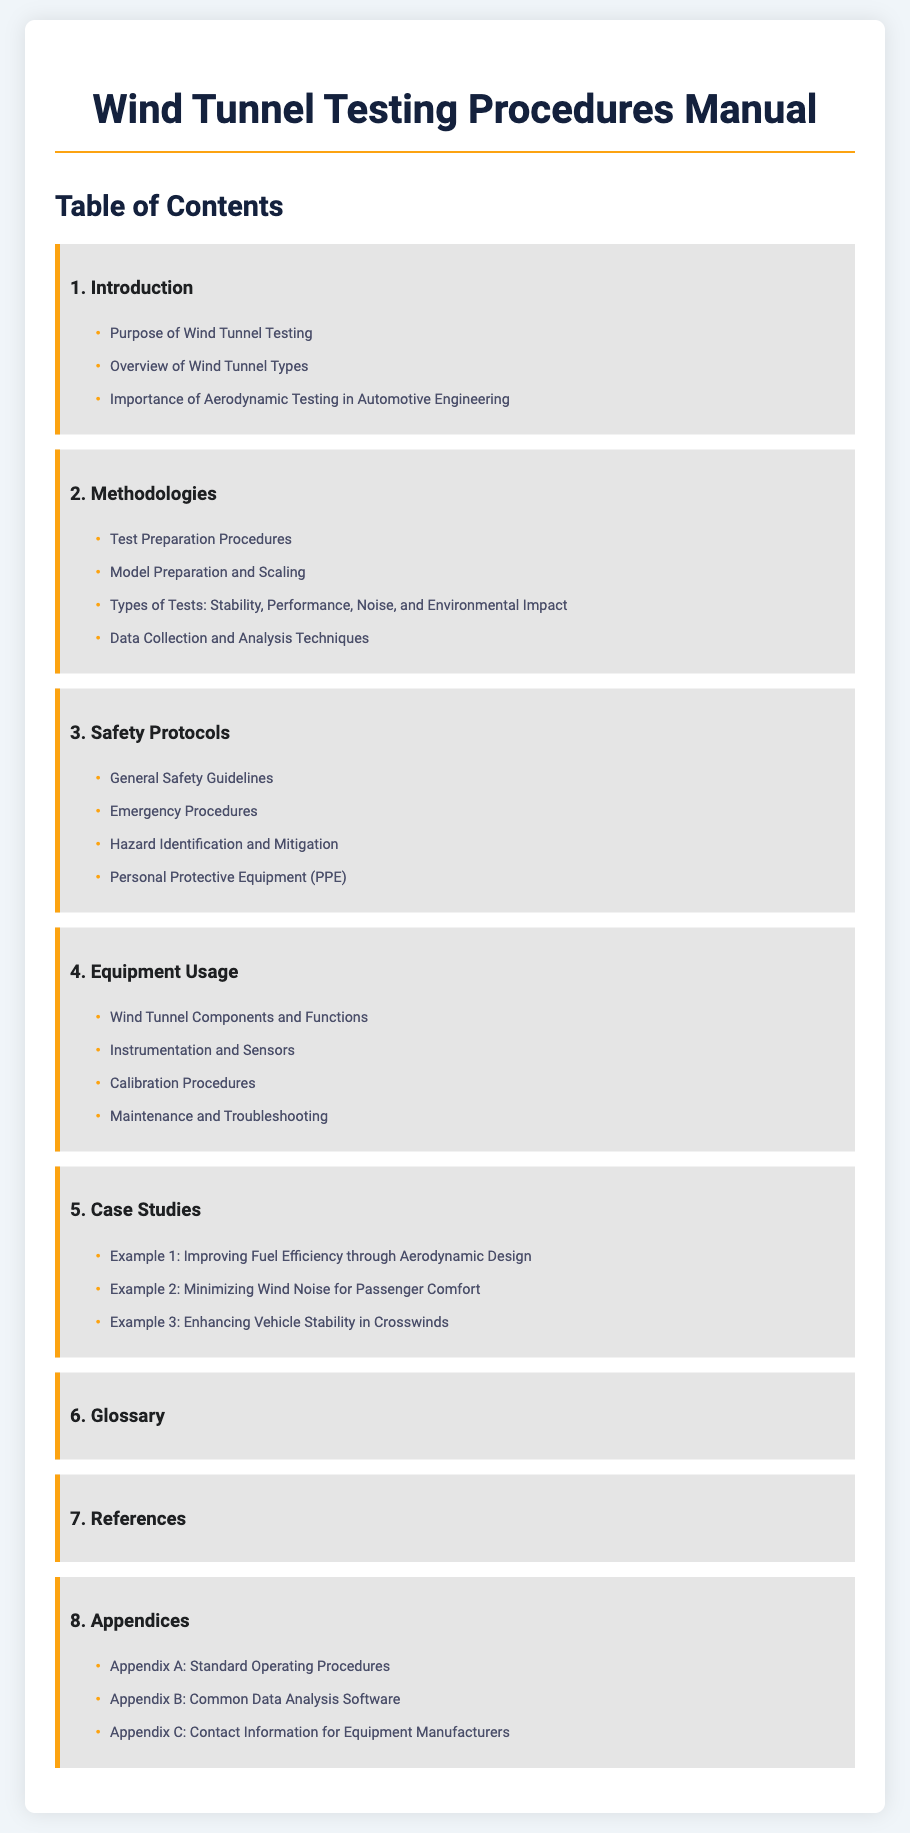what is the title of the manual? The title of the manual is provided at the top of the document.
Answer: Wind Tunnel Testing Procedures Manual how many chapters are there in the document? The total number of chapters is counted based on the listing in the Table of Contents.
Answer: 8 what is the first chapter about? The first chapter provides an introduction which is indicated in the Table of Contents.
Answer: Introduction what section discusses emergency procedures? The section related to emergency procedures is listed under Safety Protocols.
Answer: Emergency Procedures which chapter contains case studies? The chapter containing case studies is noted in the Table of Contents.
Answer: Case Studies what is mentioned in Appendix B? Appendix B details the content focus listed in the appendices section of the document.
Answer: Common Data Analysis Software what type of tests are covered under methodologies? The types of tests mentioned refer to various testing aspects outlined in the Methodologies chapter.
Answer: Stability, Performance, Noise, and Environmental Impact what is the purpose of wind tunnel testing? The purpose is typically outlined in the introductory chapter as stated in the Table of Contents.
Answer: Purpose of Wind Tunnel Testing 